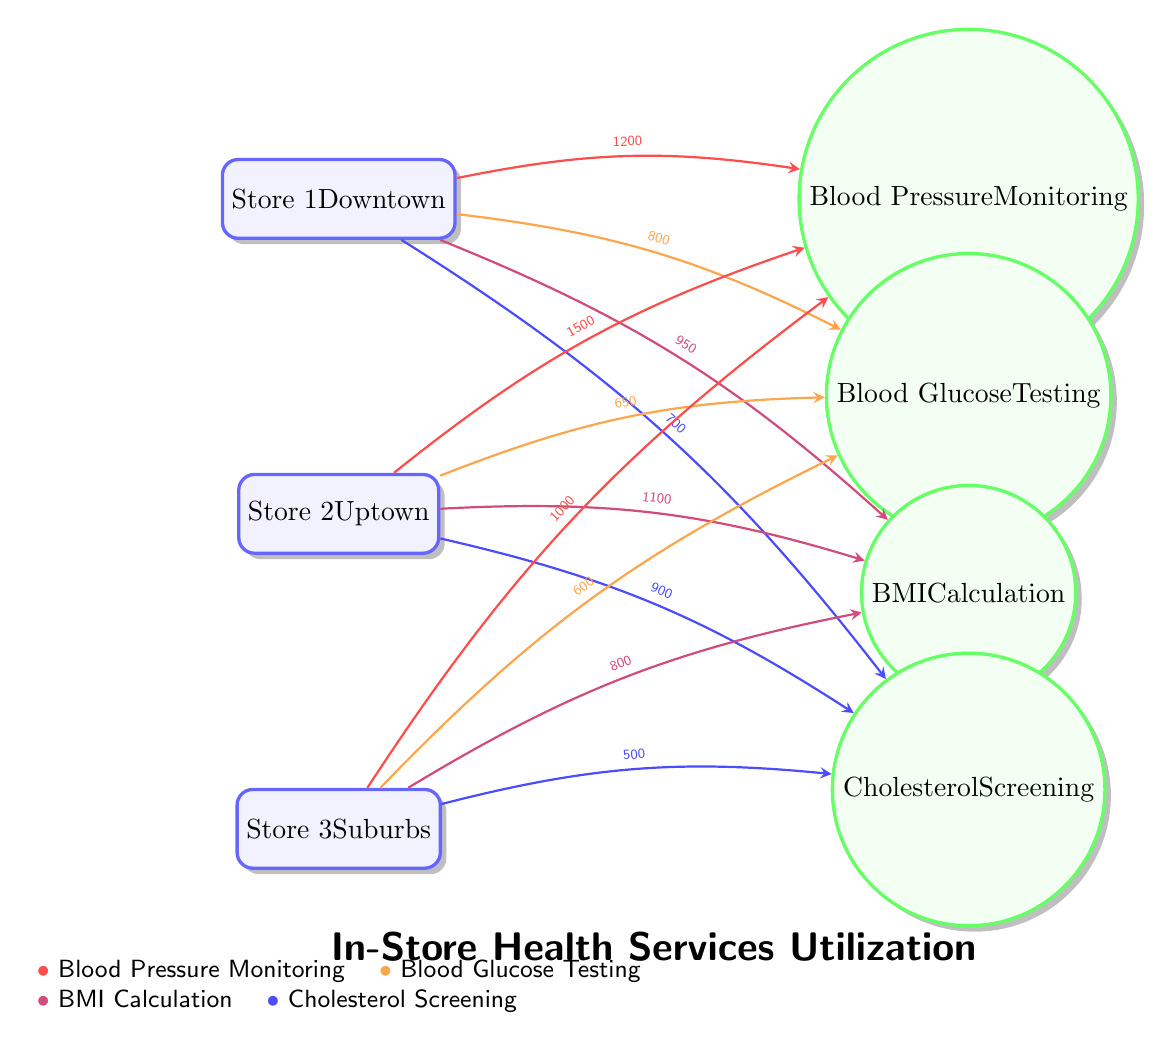What is the highest frequency of customers using blood pressure monitoring at any store? By examining the diagram, Store 2 has the highest frequency with 1500 customers using the blood pressure monitoring service. Therefore, the value associated with the connecting edge from Store 2 to the blood pressure monitoring service is the highest at 1500.
Answer: 1500 Which store has the lowest frequency of blood glucose testing? Looking at the diagram, Store 3 has the lowest frequency with 600 customers utilizing the blood glucose testing service, as indicated by the edge from Store 3 to the blood glucose testing service which shows this number.
Answer: 600 How many total services are illustrated in the diagram? The diagram illustrates four services: Blood Pressure Monitoring, Blood Glucose Testing, BMI Calculation, and Cholesterol Screening, making a total of 4 services visually represented.
Answer: 4 Which store has the highest usage of BMI calculation services? Upon reviewing the edges connecting the stores to the BMI Calculation service, Store 2 has the highest usage with 1100 customers, identified by the label on the edge connecting Store 2 to the BMI service.
Answer: 1100 If Store 1 has 800 customers utilizing blood glucose testing, how does this compare to Store 2? In the diagram, Store 1 has 800 customers for blood glucose testing, while Store 2 has 650. Thus, Store 1 has 150 more customers using this service than Store 2, derived directly from the values on the connecting edges.
Answer: 150 more What is the total number of customers using cholesterol screening across all stores? Summing the customers using cholesterol screening from each store gives: Store 1 (700) + Store 2 (900) + Store 3 (500) = 2100 total customers. This total is reached by incorporating the provided values from each connecting edge to the cholesterol screening service.
Answer: 2100 Which service is utilized the least in Store 3? A review of the edges from Store 3 shows that cholesterol screening has the least number of customers at 500, as all other service counts are higher than this number. Thus, cholesterol screening is confirmed as the least utilized service in Store 3.
Answer: Cholesterol Screening How does the blood pressure monitoring usage compare in Store 2 and Store 1? The blood pressure monitoring service usage in Store 2 (1500) exceeds that of Store 1 (1200) by 300 customers. This conclusion is based on the values given on the edges connecting each store to the blood pressure monitoring service.
Answer: 300 more in Store 2 